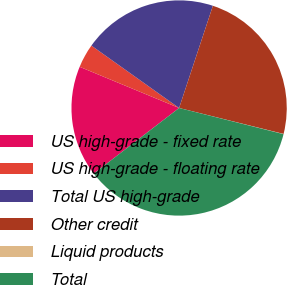Convert chart to OTSL. <chart><loc_0><loc_0><loc_500><loc_500><pie_chart><fcel>US high-grade - fixed rate<fcel>US high-grade - floating rate<fcel>Total US high-grade<fcel>Other credit<fcel>Liquid products<fcel>Total<nl><fcel>16.68%<fcel>3.59%<fcel>20.24%<fcel>23.8%<fcel>0.03%<fcel>35.66%<nl></chart> 